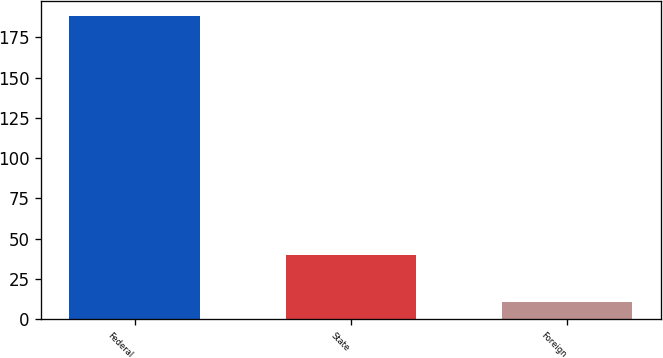Convert chart. <chart><loc_0><loc_0><loc_500><loc_500><bar_chart><fcel>Federal<fcel>State<fcel>Foreign<nl><fcel>188.1<fcel>39.8<fcel>10.4<nl></chart> 